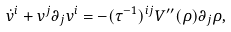Convert formula to latex. <formula><loc_0><loc_0><loc_500><loc_500>\dot { v } ^ { i } + v ^ { j } \partial _ { j } v ^ { i } = - ( \tau ^ { - 1 } ) ^ { i j } V ^ { \prime \prime } ( \rho ) \partial _ { j } \rho ,</formula> 